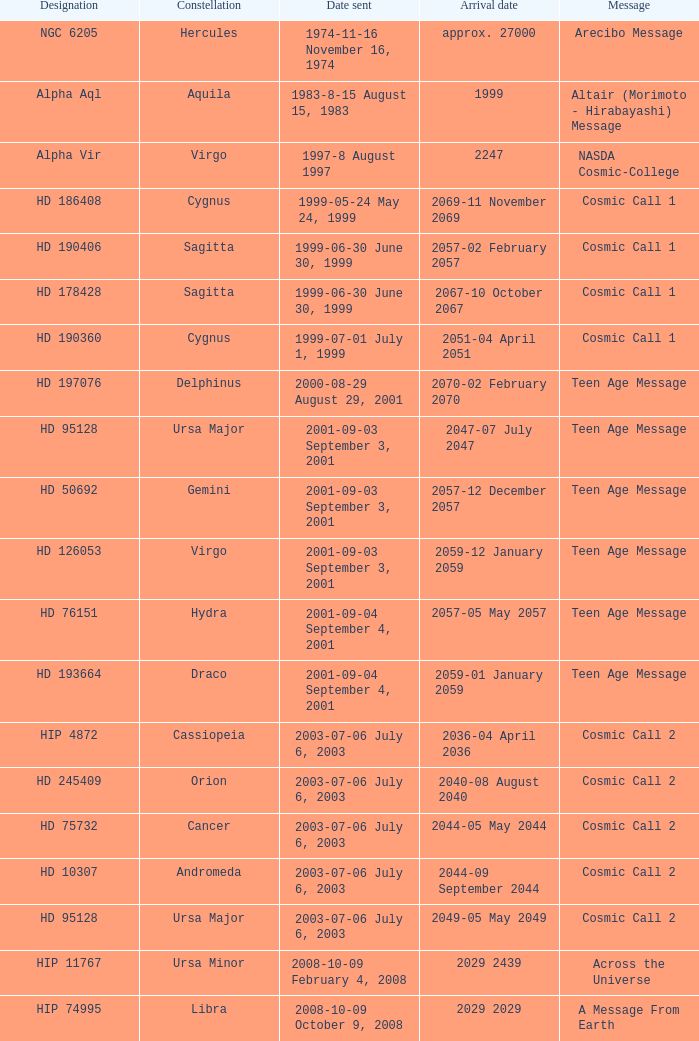Where is hip 4872 located? Cassiopeia. 